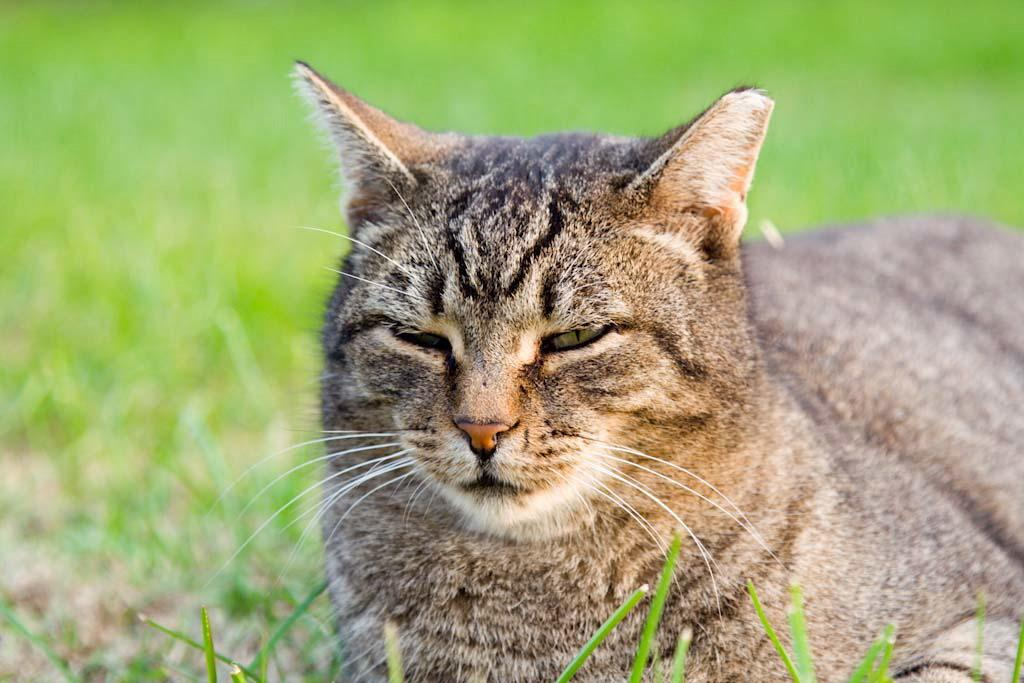What type of animal is in the image? There is a cat in the image. Can you describe the background of the image? The background of the image is blurred. Are there any fairies visible in the image? There are no fairies present in the image; it features a cat with a blurred background. 